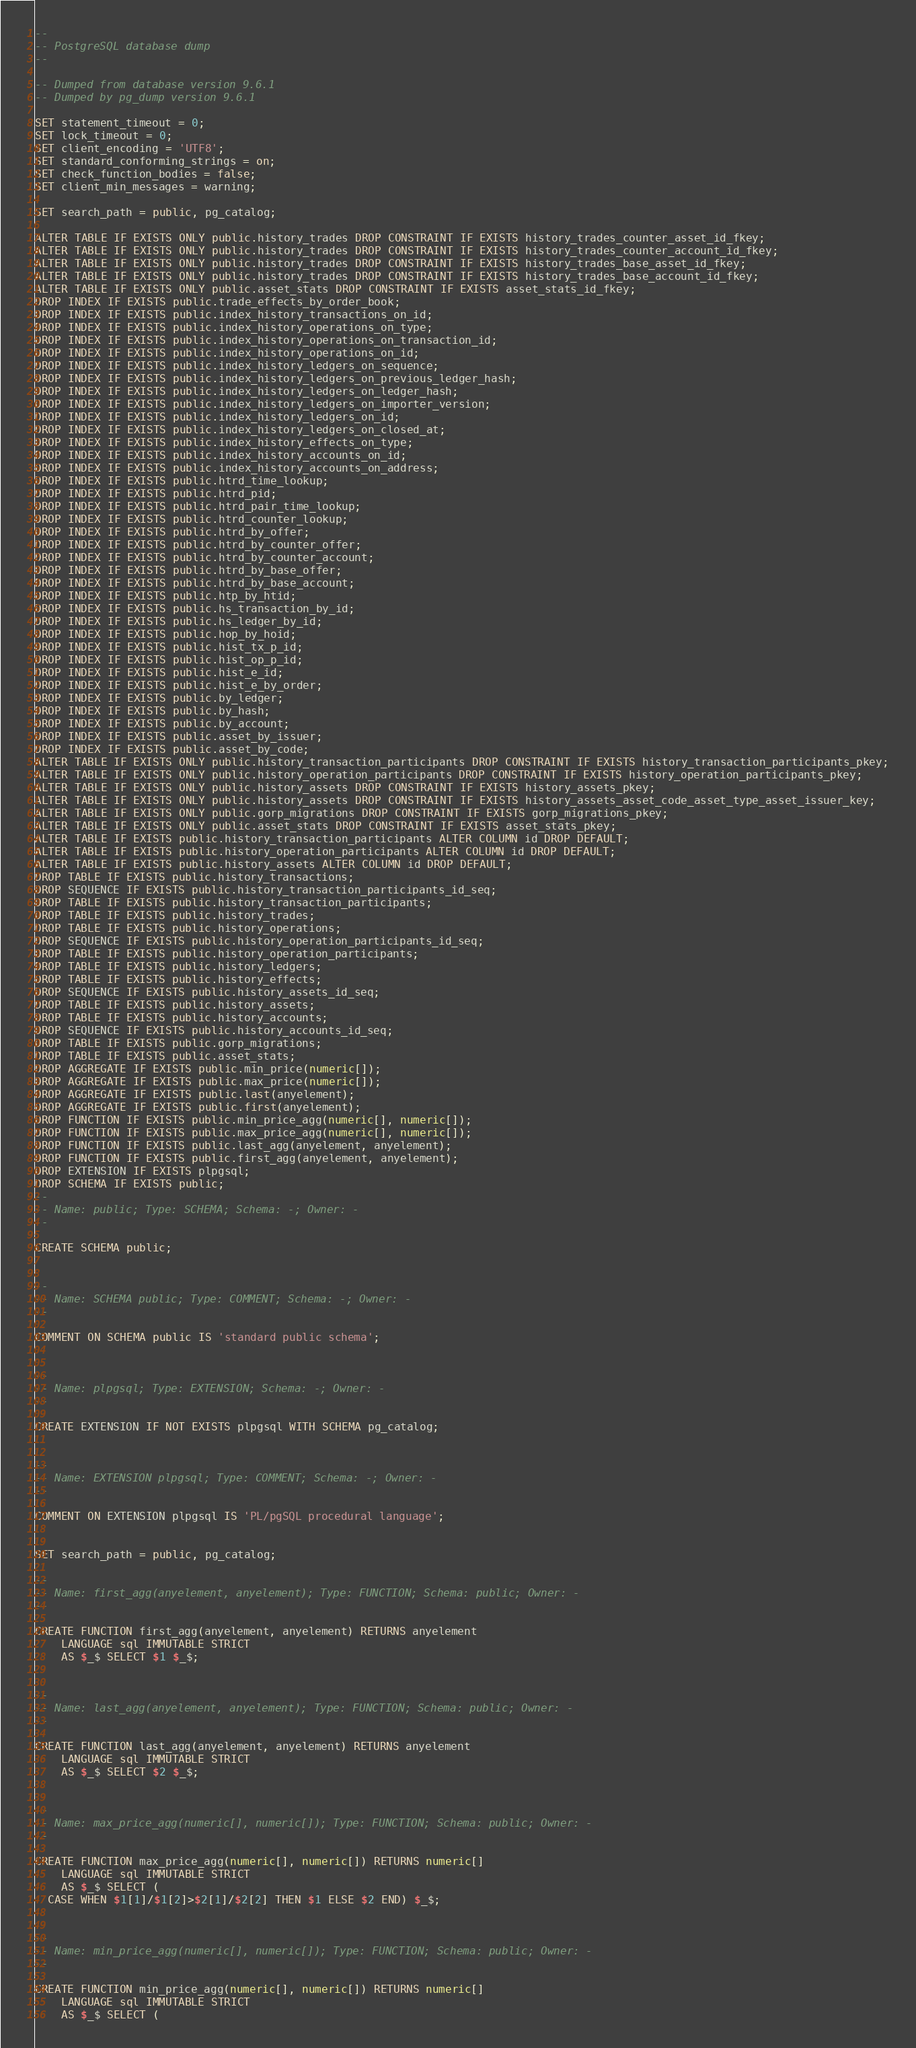Convert code to text. <code><loc_0><loc_0><loc_500><loc_500><_SQL_>--
-- PostgreSQL database dump
--

-- Dumped from database version 9.6.1
-- Dumped by pg_dump version 9.6.1

SET statement_timeout = 0;
SET lock_timeout = 0;
SET client_encoding = 'UTF8';
SET standard_conforming_strings = on;
SET check_function_bodies = false;
SET client_min_messages = warning;

SET search_path = public, pg_catalog;

ALTER TABLE IF EXISTS ONLY public.history_trades DROP CONSTRAINT IF EXISTS history_trades_counter_asset_id_fkey;
ALTER TABLE IF EXISTS ONLY public.history_trades DROP CONSTRAINT IF EXISTS history_trades_counter_account_id_fkey;
ALTER TABLE IF EXISTS ONLY public.history_trades DROP CONSTRAINT IF EXISTS history_trades_base_asset_id_fkey;
ALTER TABLE IF EXISTS ONLY public.history_trades DROP CONSTRAINT IF EXISTS history_trades_base_account_id_fkey;
ALTER TABLE IF EXISTS ONLY public.asset_stats DROP CONSTRAINT IF EXISTS asset_stats_id_fkey;
DROP INDEX IF EXISTS public.trade_effects_by_order_book;
DROP INDEX IF EXISTS public.index_history_transactions_on_id;
DROP INDEX IF EXISTS public.index_history_operations_on_type;
DROP INDEX IF EXISTS public.index_history_operations_on_transaction_id;
DROP INDEX IF EXISTS public.index_history_operations_on_id;
DROP INDEX IF EXISTS public.index_history_ledgers_on_sequence;
DROP INDEX IF EXISTS public.index_history_ledgers_on_previous_ledger_hash;
DROP INDEX IF EXISTS public.index_history_ledgers_on_ledger_hash;
DROP INDEX IF EXISTS public.index_history_ledgers_on_importer_version;
DROP INDEX IF EXISTS public.index_history_ledgers_on_id;
DROP INDEX IF EXISTS public.index_history_ledgers_on_closed_at;
DROP INDEX IF EXISTS public.index_history_effects_on_type;
DROP INDEX IF EXISTS public.index_history_accounts_on_id;
DROP INDEX IF EXISTS public.index_history_accounts_on_address;
DROP INDEX IF EXISTS public.htrd_time_lookup;
DROP INDEX IF EXISTS public.htrd_pid;
DROP INDEX IF EXISTS public.htrd_pair_time_lookup;
DROP INDEX IF EXISTS public.htrd_counter_lookup;
DROP INDEX IF EXISTS public.htrd_by_offer;
DROP INDEX IF EXISTS public.htrd_by_counter_offer;
DROP INDEX IF EXISTS public.htrd_by_counter_account;
DROP INDEX IF EXISTS public.htrd_by_base_offer;
DROP INDEX IF EXISTS public.htrd_by_base_account;
DROP INDEX IF EXISTS public.htp_by_htid;
DROP INDEX IF EXISTS public.hs_transaction_by_id;
DROP INDEX IF EXISTS public.hs_ledger_by_id;
DROP INDEX IF EXISTS public.hop_by_hoid;
DROP INDEX IF EXISTS public.hist_tx_p_id;
DROP INDEX IF EXISTS public.hist_op_p_id;
DROP INDEX IF EXISTS public.hist_e_id;
DROP INDEX IF EXISTS public.hist_e_by_order;
DROP INDEX IF EXISTS public.by_ledger;
DROP INDEX IF EXISTS public.by_hash;
DROP INDEX IF EXISTS public.by_account;
DROP INDEX IF EXISTS public.asset_by_issuer;
DROP INDEX IF EXISTS public.asset_by_code;
ALTER TABLE IF EXISTS ONLY public.history_transaction_participants DROP CONSTRAINT IF EXISTS history_transaction_participants_pkey;
ALTER TABLE IF EXISTS ONLY public.history_operation_participants DROP CONSTRAINT IF EXISTS history_operation_participants_pkey;
ALTER TABLE IF EXISTS ONLY public.history_assets DROP CONSTRAINT IF EXISTS history_assets_pkey;
ALTER TABLE IF EXISTS ONLY public.history_assets DROP CONSTRAINT IF EXISTS history_assets_asset_code_asset_type_asset_issuer_key;
ALTER TABLE IF EXISTS ONLY public.gorp_migrations DROP CONSTRAINT IF EXISTS gorp_migrations_pkey;
ALTER TABLE IF EXISTS ONLY public.asset_stats DROP CONSTRAINT IF EXISTS asset_stats_pkey;
ALTER TABLE IF EXISTS public.history_transaction_participants ALTER COLUMN id DROP DEFAULT;
ALTER TABLE IF EXISTS public.history_operation_participants ALTER COLUMN id DROP DEFAULT;
ALTER TABLE IF EXISTS public.history_assets ALTER COLUMN id DROP DEFAULT;
DROP TABLE IF EXISTS public.history_transactions;
DROP SEQUENCE IF EXISTS public.history_transaction_participants_id_seq;
DROP TABLE IF EXISTS public.history_transaction_participants;
DROP TABLE IF EXISTS public.history_trades;
DROP TABLE IF EXISTS public.history_operations;
DROP SEQUENCE IF EXISTS public.history_operation_participants_id_seq;
DROP TABLE IF EXISTS public.history_operation_participants;
DROP TABLE IF EXISTS public.history_ledgers;
DROP TABLE IF EXISTS public.history_effects;
DROP SEQUENCE IF EXISTS public.history_assets_id_seq;
DROP TABLE IF EXISTS public.history_assets;
DROP TABLE IF EXISTS public.history_accounts;
DROP SEQUENCE IF EXISTS public.history_accounts_id_seq;
DROP TABLE IF EXISTS public.gorp_migrations;
DROP TABLE IF EXISTS public.asset_stats;
DROP AGGREGATE IF EXISTS public.min_price(numeric[]);
DROP AGGREGATE IF EXISTS public.max_price(numeric[]);
DROP AGGREGATE IF EXISTS public.last(anyelement);
DROP AGGREGATE IF EXISTS public.first(anyelement);
DROP FUNCTION IF EXISTS public.min_price_agg(numeric[], numeric[]);
DROP FUNCTION IF EXISTS public.max_price_agg(numeric[], numeric[]);
DROP FUNCTION IF EXISTS public.last_agg(anyelement, anyelement);
DROP FUNCTION IF EXISTS public.first_agg(anyelement, anyelement);
DROP EXTENSION IF EXISTS plpgsql;
DROP SCHEMA IF EXISTS public;
--
-- Name: public; Type: SCHEMA; Schema: -; Owner: -
--

CREATE SCHEMA public;


--
-- Name: SCHEMA public; Type: COMMENT; Schema: -; Owner: -
--

COMMENT ON SCHEMA public IS 'standard public schema';


--
-- Name: plpgsql; Type: EXTENSION; Schema: -; Owner: -
--

CREATE EXTENSION IF NOT EXISTS plpgsql WITH SCHEMA pg_catalog;


--
-- Name: EXTENSION plpgsql; Type: COMMENT; Schema: -; Owner: -
--

COMMENT ON EXTENSION plpgsql IS 'PL/pgSQL procedural language';


SET search_path = public, pg_catalog;

--
-- Name: first_agg(anyelement, anyelement); Type: FUNCTION; Schema: public; Owner: -
--

CREATE FUNCTION first_agg(anyelement, anyelement) RETURNS anyelement
    LANGUAGE sql IMMUTABLE STRICT
    AS $_$ SELECT $1 $_$;


--
-- Name: last_agg(anyelement, anyelement); Type: FUNCTION; Schema: public; Owner: -
--

CREATE FUNCTION last_agg(anyelement, anyelement) RETURNS anyelement
    LANGUAGE sql IMMUTABLE STRICT
    AS $_$ SELECT $2 $_$;


--
-- Name: max_price_agg(numeric[], numeric[]); Type: FUNCTION; Schema: public; Owner: -
--

CREATE FUNCTION max_price_agg(numeric[], numeric[]) RETURNS numeric[]
    LANGUAGE sql IMMUTABLE STRICT
    AS $_$ SELECT (
  CASE WHEN $1[1]/$1[2]>$2[1]/$2[2] THEN $1 ELSE $2 END) $_$;


--
-- Name: min_price_agg(numeric[], numeric[]); Type: FUNCTION; Schema: public; Owner: -
--

CREATE FUNCTION min_price_agg(numeric[], numeric[]) RETURNS numeric[]
    LANGUAGE sql IMMUTABLE STRICT
    AS $_$ SELECT (</code> 